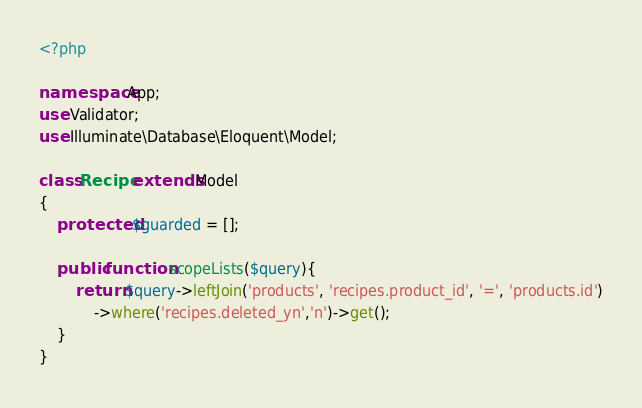<code> <loc_0><loc_0><loc_500><loc_500><_PHP_><?php

namespace App;
use Validator;
use Illuminate\Database\Eloquent\Model;

class Recipe extends Model
{
    protected $guarded = [];

    public function scopeLists($query){
        return $query->leftJoin('products', 'recipes.product_id', '=', 'products.id')
            ->where('recipes.deleted_yn','n')->get();
    }
}
</code> 